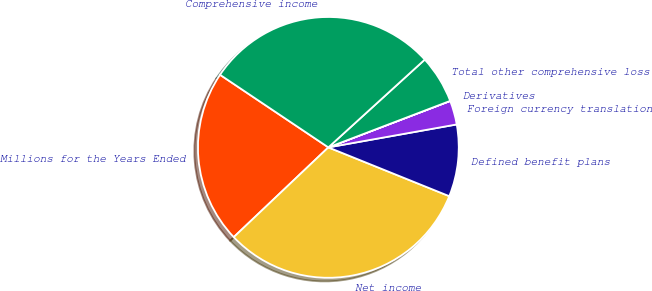<chart> <loc_0><loc_0><loc_500><loc_500><pie_chart><fcel>Millions for the Years Ended<fcel>Net income<fcel>Defined benefit plans<fcel>Foreign currency translation<fcel>Derivatives<fcel>Total other comprehensive loss<fcel>Comprehensive income<nl><fcel>21.48%<fcel>31.82%<fcel>8.92%<fcel>2.98%<fcel>0.01%<fcel>5.95%<fcel>28.85%<nl></chart> 